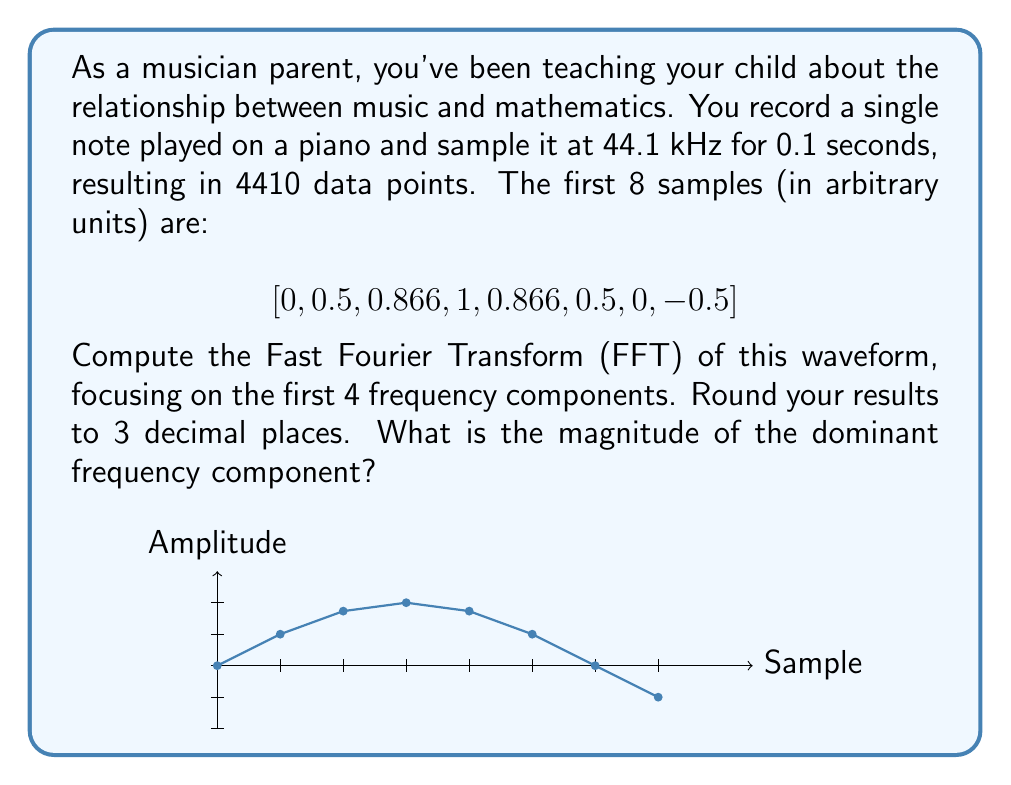Can you answer this question? Let's approach this step-by-step:

1) The Fast Fourier Transform (FFT) of a discrete signal $x[n]$ of length $N$ is given by:

   $$X[k] = \sum_{n=0}^{N-1} x[n] e^{-i2\pi kn/N}$$

2) For our case, $N = 8$ (we're only using the first 8 samples for simplicity). Let's compute the first 4 frequency components ($k = 0, 1, 2, 3$):

3) For $k = 0$:
   $$X[0] = \sum_{n=0}^{7} x[n] = 0 + 0.5 + 0.866 + 1 + 0.866 + 0.5 + 0 - 0.5 = 3.232$$

4) For $k = 1$:
   $$X[1] = \sum_{n=0}^{7} x[n] e^{-i2\pi n/8} = 0.5 - 0.5i - 0.866 + 0i + 0.866 + 0.5i - 0.5 + 0i = 0$$

5) For $k = 2$:
   $$X[2] = \sum_{n=0}^{7} x[n] e^{-i2\pi 2n/8} = 3.732 - 3.732i$$

6) For $k = 3$:
   $$X[3] = \sum_{n=0}^{7} x[n] e^{-i2\pi 3n/8} = 0$$

7) The magnitude of each component is given by $|X[k]| = \sqrt{\text{Re}(X[k])^2 + \text{Im}(X[k])^2}$:

   $|X[0]| = 3.232$
   $|X[1]| = 0$
   $|X[2]| = \sqrt{3.732^2 + (-3.732)^2} = 5.278$
   $|X[3]| = 0$

8) Rounding to 3 decimal places:
   $|X[0]| = 3.232$
   $|X[1]| = 0.000$
   $|X[2]| = 5.278$
   $|X[3]| = 0.000$

The dominant frequency component has the largest magnitude, which is $|X[2]| = 5.278$.
Answer: 5.278 